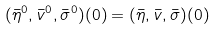<formula> <loc_0><loc_0><loc_500><loc_500>( \bar { \eta } ^ { 0 } , \bar { v } ^ { 0 } , \bar { \sigma } ^ { 0 } ) ( 0 ) = ( \bar { \eta } , \bar { v } , \bar { \sigma } ) ( 0 )</formula> 